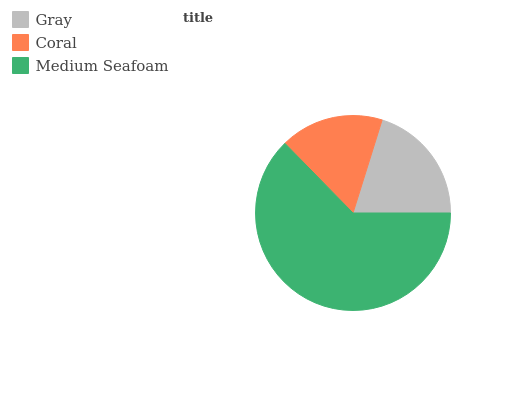Is Coral the minimum?
Answer yes or no. Yes. Is Medium Seafoam the maximum?
Answer yes or no. Yes. Is Medium Seafoam the minimum?
Answer yes or no. No. Is Coral the maximum?
Answer yes or no. No. Is Medium Seafoam greater than Coral?
Answer yes or no. Yes. Is Coral less than Medium Seafoam?
Answer yes or no. Yes. Is Coral greater than Medium Seafoam?
Answer yes or no. No. Is Medium Seafoam less than Coral?
Answer yes or no. No. Is Gray the high median?
Answer yes or no. Yes. Is Gray the low median?
Answer yes or no. Yes. Is Medium Seafoam the high median?
Answer yes or no. No. Is Coral the low median?
Answer yes or no. No. 